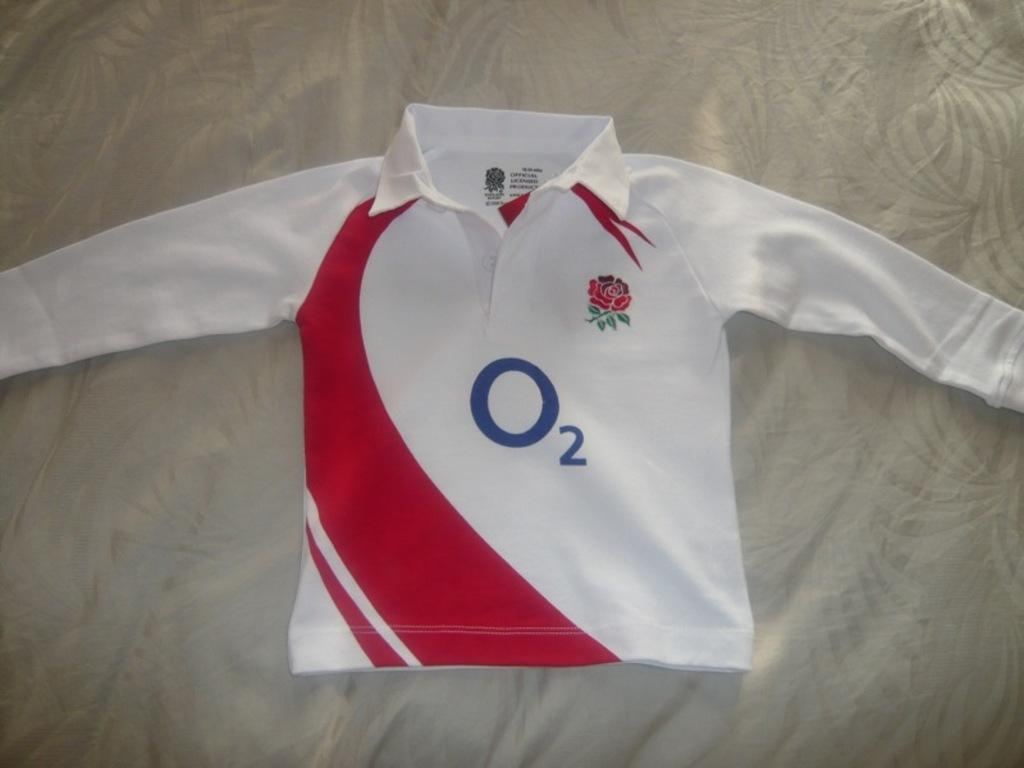<image>
Present a compact description of the photo's key features. a jersey with the letter O on it 